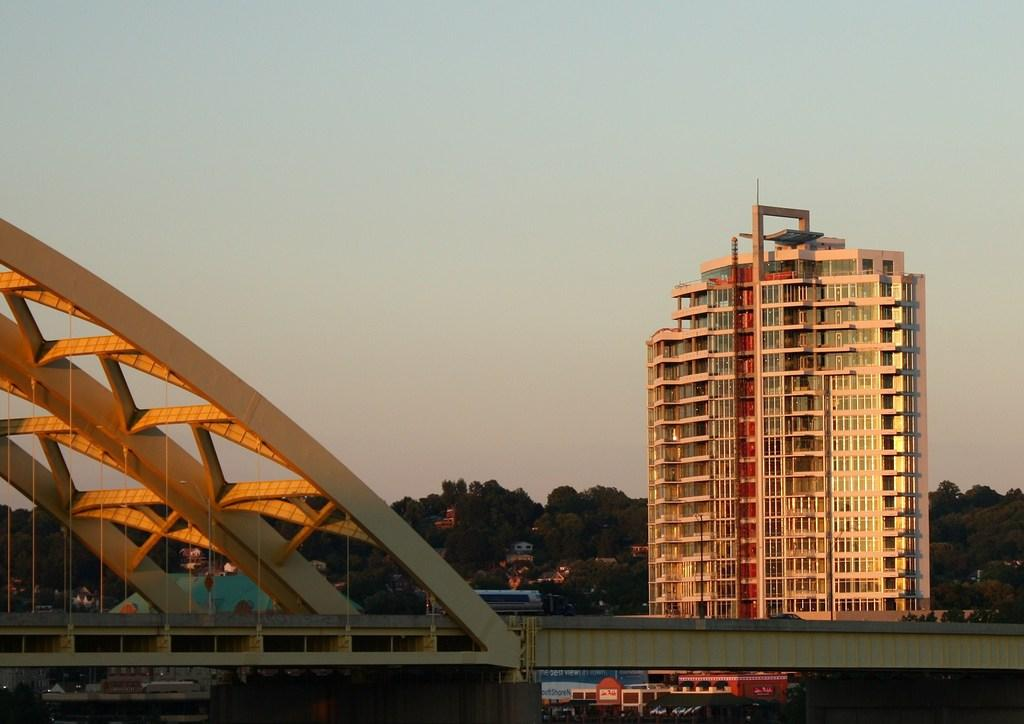What type of structure can be seen in the image? There is a bridge in the image. What else is present in the image besides the bridge? There are buildings and trees in the image. What can be seen in the background of the image? The sky is visible in the background of the image. How many boys are holding a bead on the bridge in the image? There are no boys or beads present in the image; it only features a bridge, buildings, trees, and the sky. 